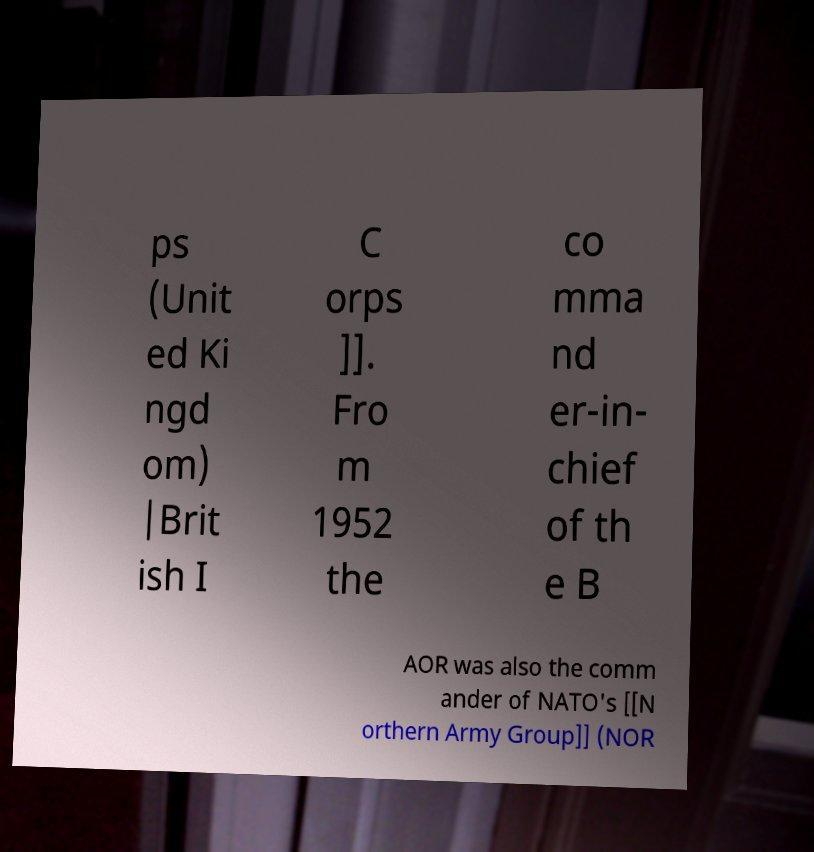What messages or text are displayed in this image? I need them in a readable, typed format. ps (Unit ed Ki ngd om) |Brit ish I C orps ]]. Fro m 1952 the co mma nd er-in- chief of th e B AOR was also the comm ander of NATO's [[N orthern Army Group]] (NOR 